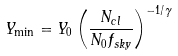Convert formula to latex. <formula><loc_0><loc_0><loc_500><loc_500>Y _ { \min } = Y _ { 0 } \left ( \frac { N _ { c l } } { N _ { 0 } f _ { s k y } } \right ) ^ { - 1 / \gamma }</formula> 